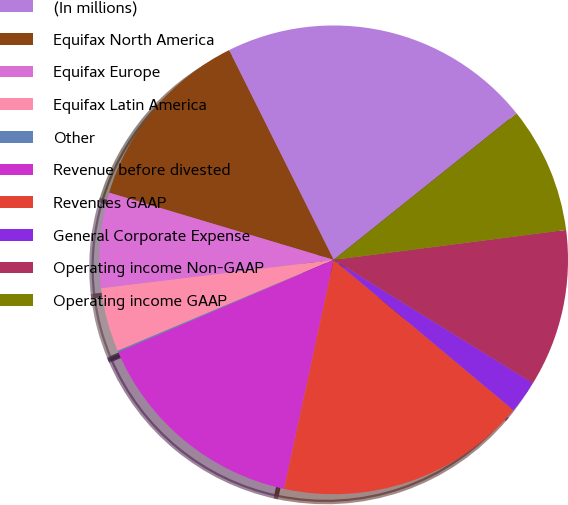Convert chart to OTSL. <chart><loc_0><loc_0><loc_500><loc_500><pie_chart><fcel>(In millions)<fcel>Equifax North America<fcel>Equifax Europe<fcel>Equifax Latin America<fcel>Other<fcel>Revenue before divested<fcel>Revenues GAAP<fcel>General Corporate Expense<fcel>Operating income Non-GAAP<fcel>Operating income GAAP<nl><fcel>21.62%<fcel>13.01%<fcel>6.56%<fcel>4.41%<fcel>0.1%<fcel>15.16%<fcel>17.31%<fcel>2.26%<fcel>10.86%<fcel>8.71%<nl></chart> 